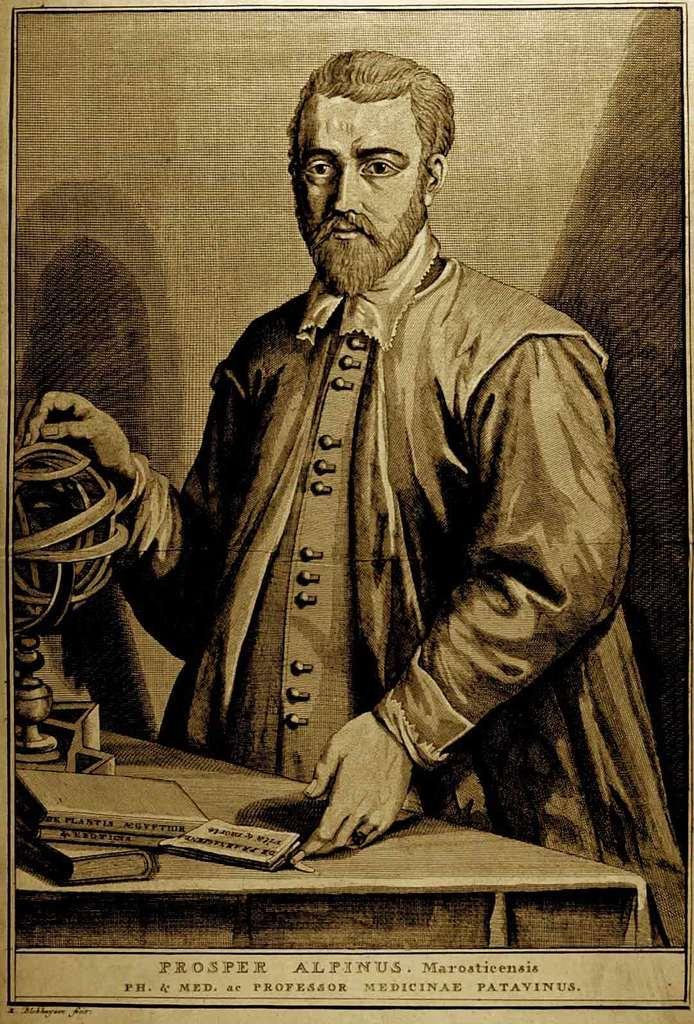Describe this image in one or two sentences. This is an animated image in this image in the center there is one person who is standing, in front of him there is one table on the table there is one globe and some books. At the bottom of the image there is some text written. 